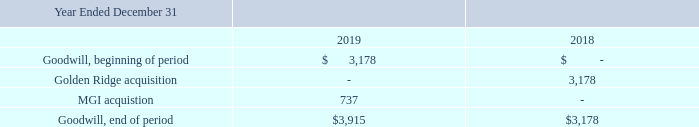NOTE 9. GOODWILL AND INTANGIBLES
A summary of goodwill activity follows (in thousands).
What are the respective goodwill at the end of the period in 2018 and 2019?
Answer scale should be: thousand. $3,178, $3,915. What is the value of the goodwill from the Golden Ridge acquisition in 2018?
Answer scale should be: thousand. 3,178. What is the value of the goodwill from the MGI acquisition in 2019?
Answer scale should be: thousand. 737. What is the percentage change in goodwill at the end of the period at 2018 and 2019?
Answer scale should be: percent. (3,915 - 3,178)/3,178 
Answer: 23.19. What is the total goodwill obtained from acquisitions in 2018 and 2019?
Answer scale should be: thousand. 3,178 + 737 
Answer: 3915. What is the difference in goodwill between the acquisitions made in 2018 and 2019?
Answer scale should be: thousand. 3,178 - 737 
Answer: 2441. 